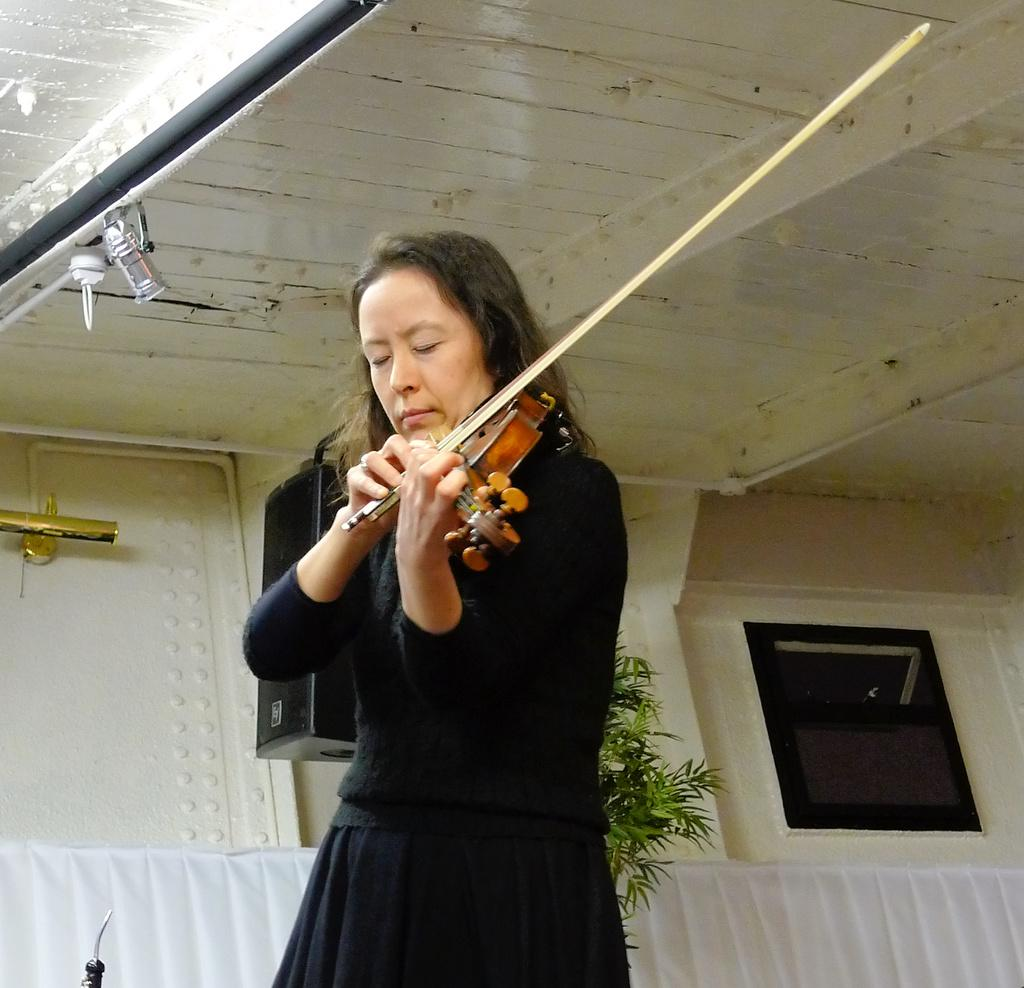Where is the image taken? The image is taken outside a building. What is the lady in the image doing? The lady is playing the violin. What is the lady wearing? The lady is wearing a black dress. What can be seen behind the lady? There is a speaker behind the lady. What type of bells can be heard ringing in the image? There are no bells present in the image, and therefore no ringing can be heard. Is there any soda visible in the image? There is no soda present in the image. 